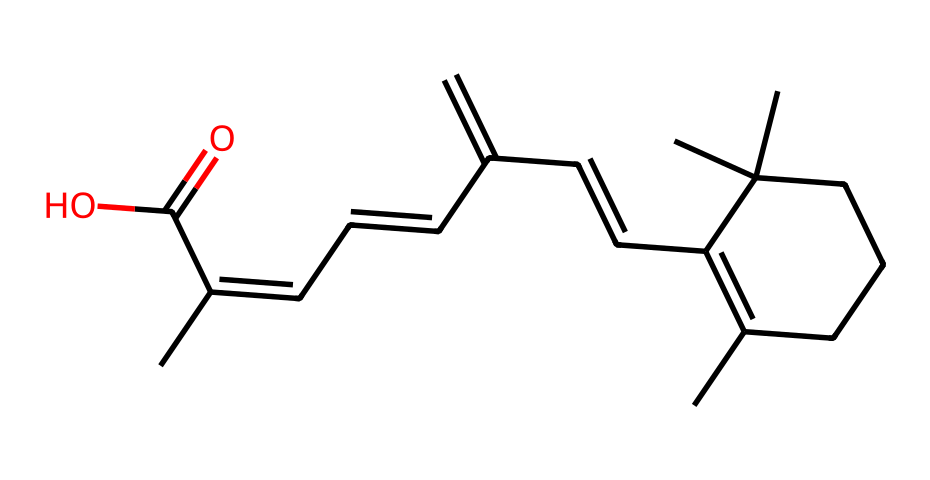How many carbon atoms are in the structure? By counting the number of 'C' in the SMILES notation and noting each carbon atom contributes to the molecular framework. The given SMILES contains 20 carbon atoms in total.
Answer: 20 What functional group does this molecule contain? By examining the structure, we identify the carboxylic acid group represented by "C(=O)O", indicating that it has a functional group associated with acidity and reactivity in biological systems.
Answer: carboxylic acid What is the total number of double bonds in this molecule? The presence of double bonds can be found by identifying each "=" in the SMILES representation. Upon examination, there are 5 double bonds present in the structure.
Answer: 5 What is the molecular formula for this compound? The molecular formula can be derived by counting each type of atom from the SMILES: C: 20, H: 30, O: 2, thus leading to the molecular formula C20H30O2.
Answer: C20H30O2 Can this molecule act as an antioxidant? Given that retinol is known for its antioxidant properties, which are derived from its molecular structure that allows for the stabilization of free radicals, it is reasonable to conclude that this molecule can act in that capacity.
Answer: yes What role does the presence of multiple methyl groups play in this molecule? Multiple methyl groups, as seen in the structure, contribute to the lipophilicity of the molecule, making it more soluble in fats and enhancing its penetration into the skin. This property is important for its effectiveness in cosmetic formulations.
Answer: enhances solubility 